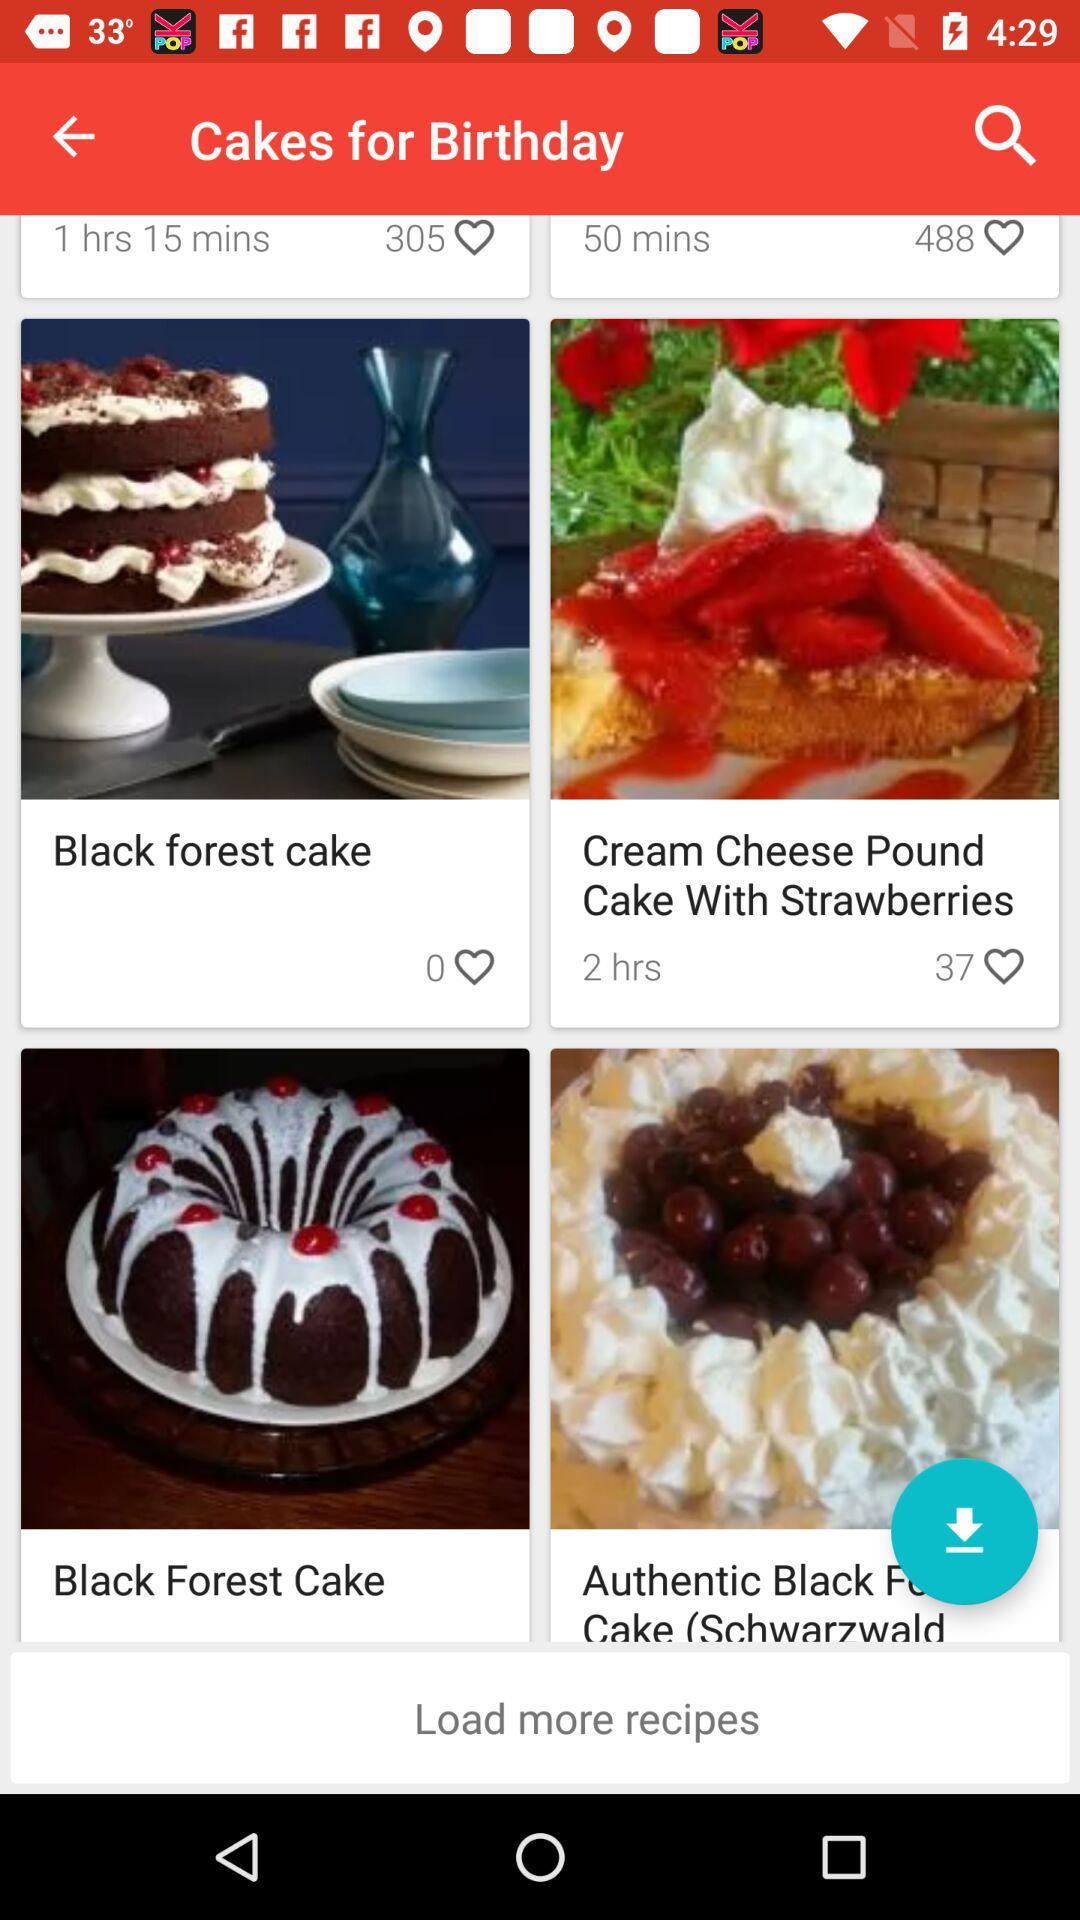How many likes are on "Cream Cheese Pound Cake With Strawberries"? There are 37 likes. 